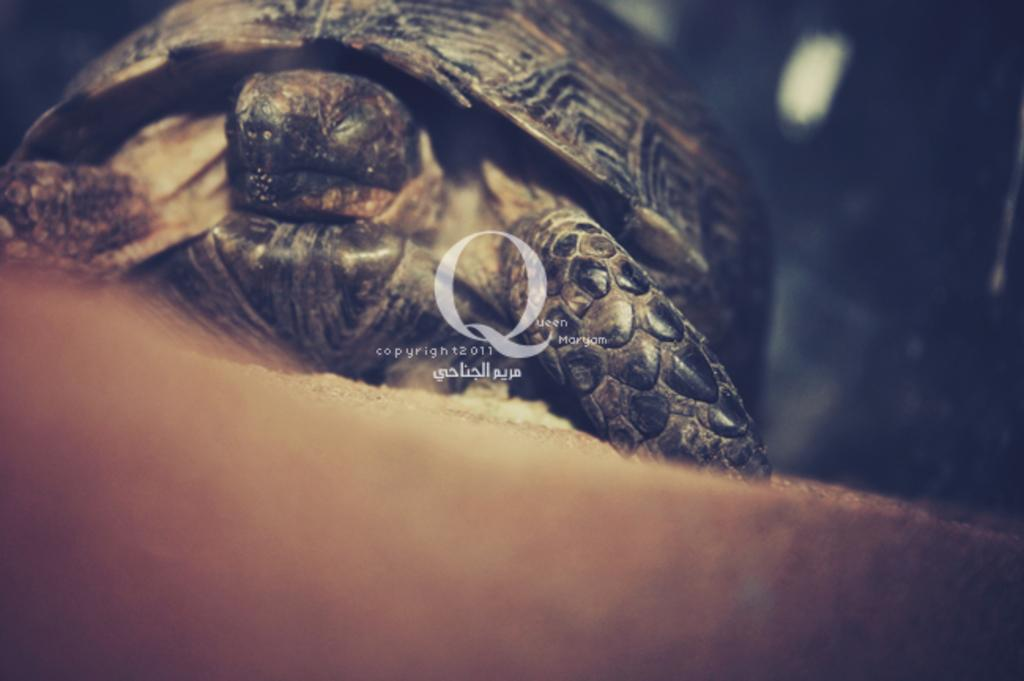What type of animal is in the image? There is a tortoise in the image. What colors can be seen on the tortoise? The tortoise has brown, black, and cream colors. What color is the background of the image? The background of the image is black. What type of polish is the tortoise using in the image? There is no indication in the image that the tortoise is using any polish. 